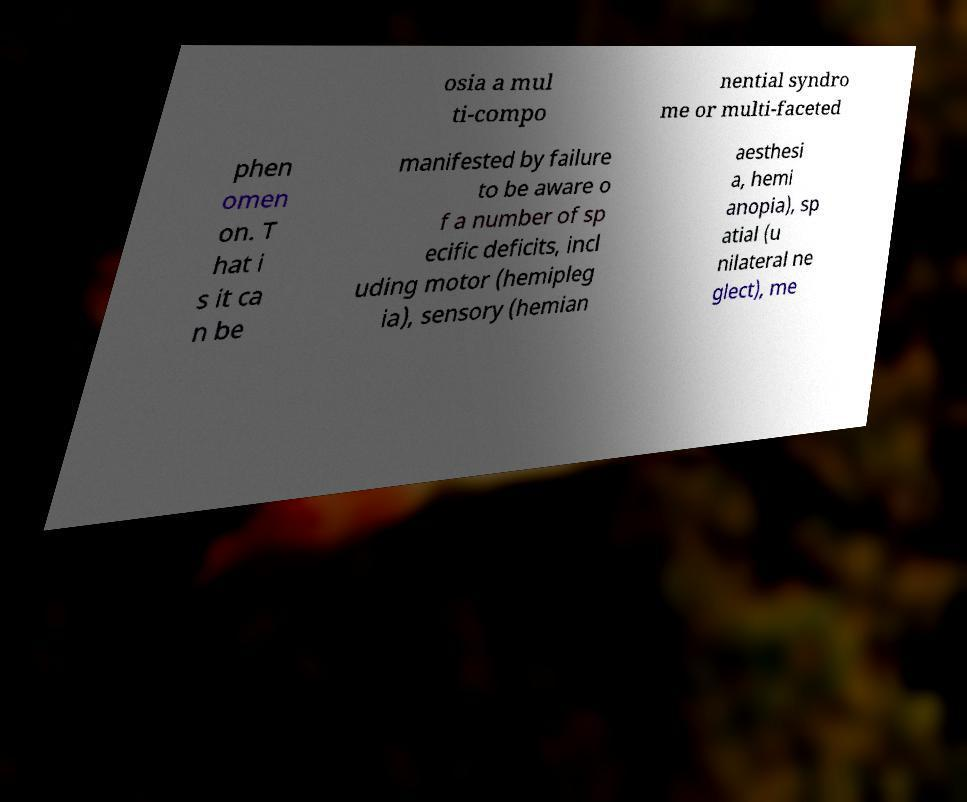Could you extract and type out the text from this image? osia a mul ti-compo nential syndro me or multi-faceted phen omen on. T hat i s it ca n be manifested by failure to be aware o f a number of sp ecific deficits, incl uding motor (hemipleg ia), sensory (hemian aesthesi a, hemi anopia), sp atial (u nilateral ne glect), me 